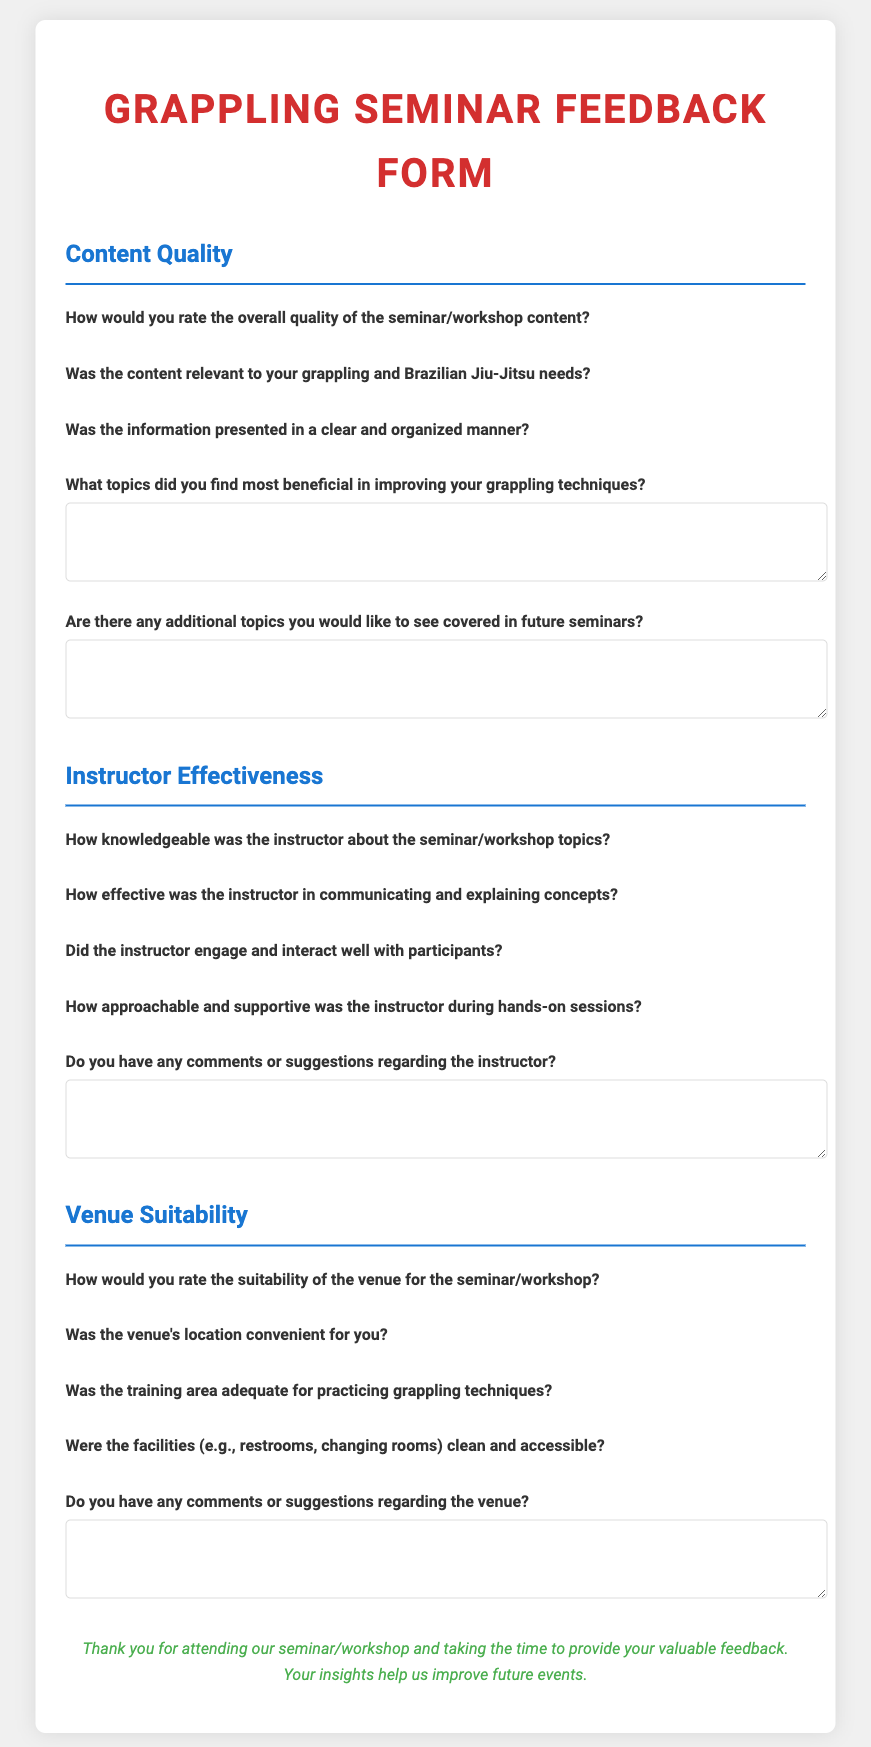How many main sections are in the feedback form? The document contains three main sections: Content Quality, Instructor Effectiveness, and Venue Suitability.
Answer: 3 What is the rating scale used in the document? The feedback form uses a 1 to 5 star rating scale, where 1 is the lowest and 5 is the highest.
Answer: 1 to 5 What is the title of the feedback form? The title of the form is presented at the top of the document in a large font.
Answer: Grappling Seminar Feedback Form How many questions are there under the "Instructor Effectiveness" section? The document contains five questions in the Instructor Effectiveness section.
Answer: 5 What is the color of the headings in the document? The headings are styled in blue and red colors to differentiate them and highlight their importance.
Answer: Blue and Red What type of response is allowed for the questions regarding beneficial topics? The form allows open-ended responses for the question about beneficial topics through a text area.
Answer: Open-ended What aspect of the venue does the fourth question under "Venue Suitability" focus on? The fourth question focuses on the cleanliness and accessibility of the facilities, such as restrooms and changing rooms.
Answer: Cleanliness and Accessibility What feedback does the form request after the content quality questions? The form requests comments regarding the instructor after the questions about content quality.
Answer: Comments regarding the instructor 